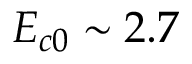Convert formula to latex. <formula><loc_0><loc_0><loc_500><loc_500>E _ { c 0 } \sim 2 . 7</formula> 